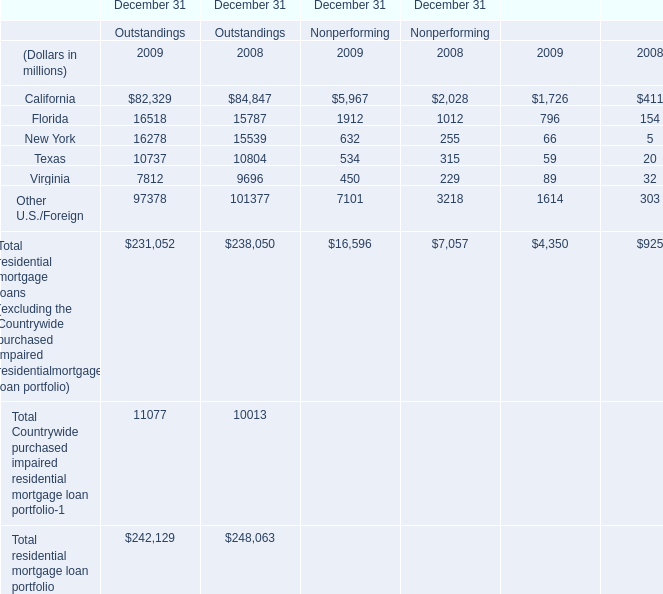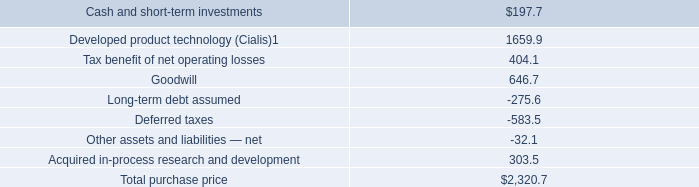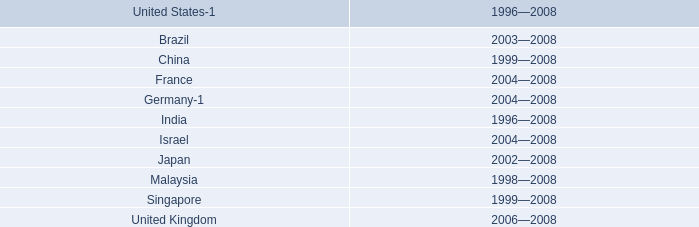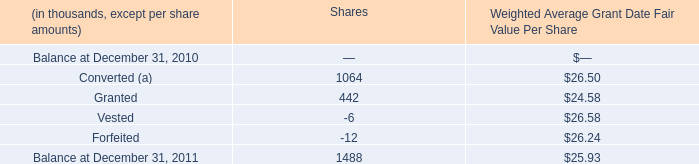What is the sum of Other U.S./Foreign of December 31 Nonperforming 2009, and Balance at December 31, 2011 of Shares — ? 
Computations: (7101.0 + 1488.0)
Answer: 8589.0. 